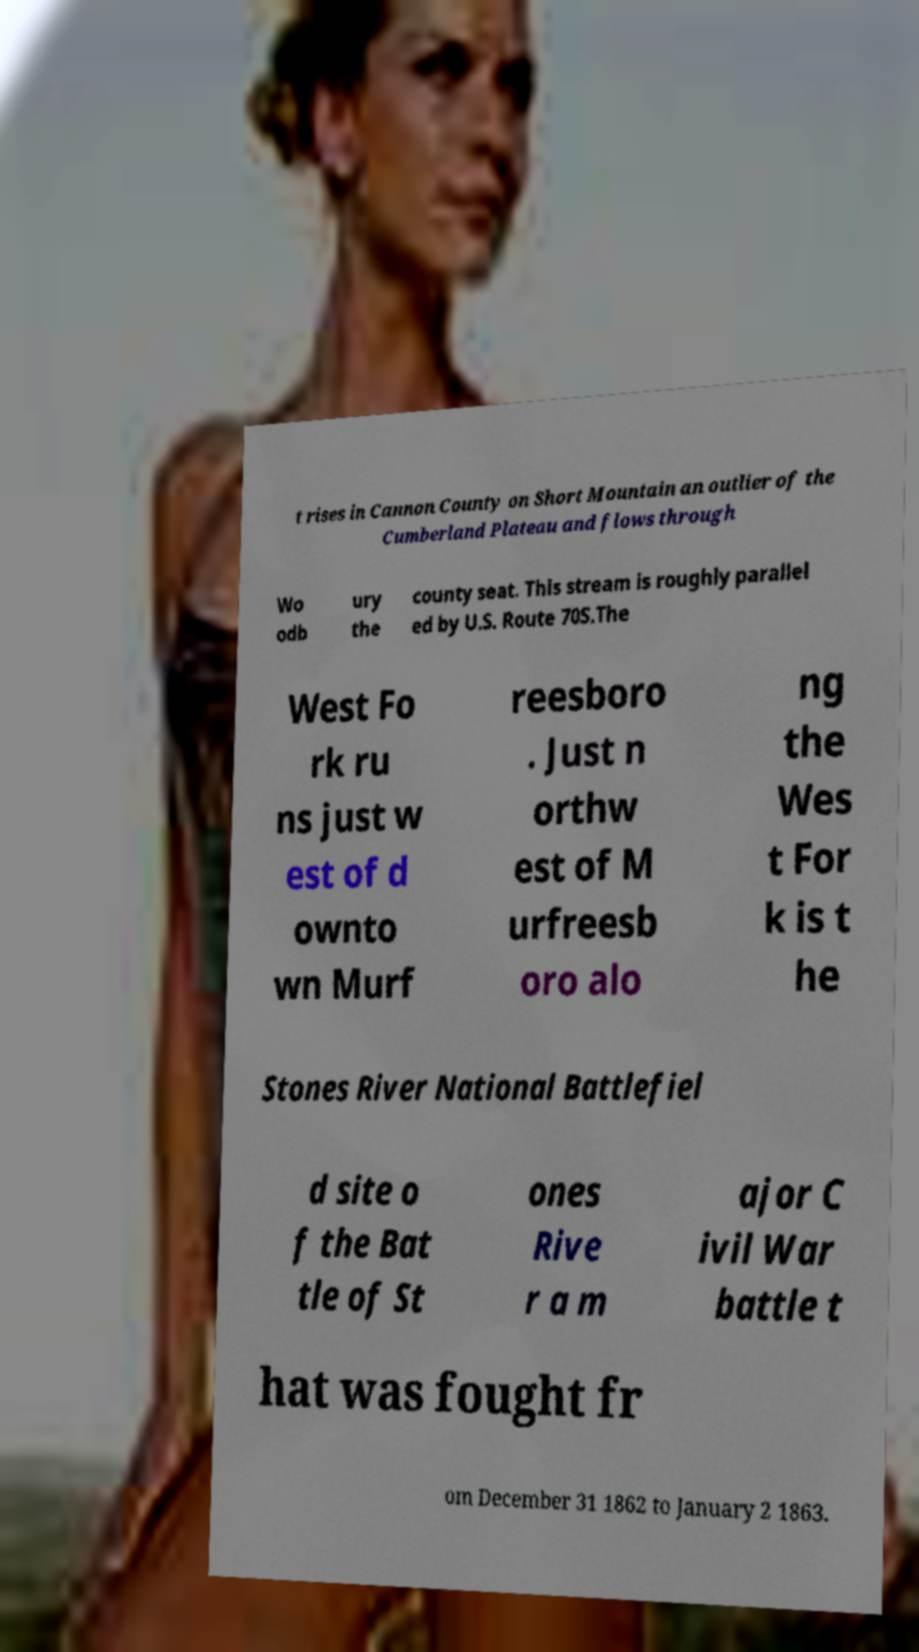Can you read and provide the text displayed in the image?This photo seems to have some interesting text. Can you extract and type it out for me? t rises in Cannon County on Short Mountain an outlier of the Cumberland Plateau and flows through Wo odb ury the county seat. This stream is roughly parallel ed by U.S. Route 70S.The West Fo rk ru ns just w est of d ownto wn Murf reesboro . Just n orthw est of M urfreesb oro alo ng the Wes t For k is t he Stones River National Battlefiel d site o f the Bat tle of St ones Rive r a m ajor C ivil War battle t hat was fought fr om December 31 1862 to January 2 1863. 